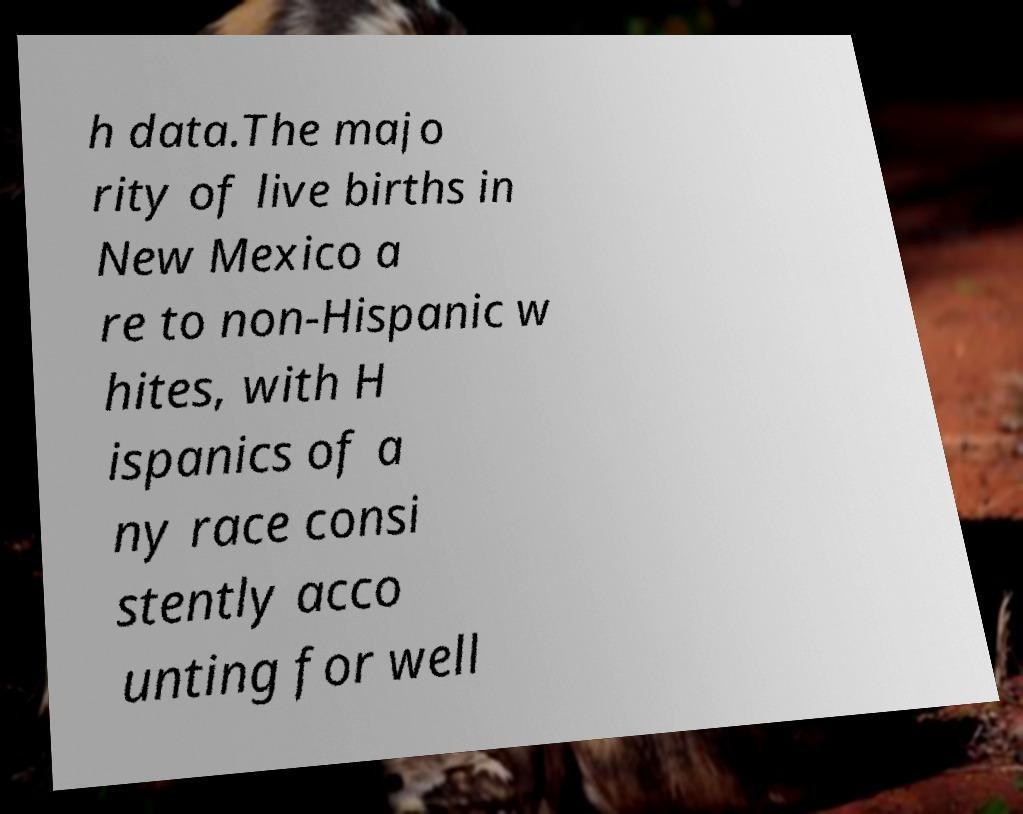There's text embedded in this image that I need extracted. Can you transcribe it verbatim? h data.The majo rity of live births in New Mexico a re to non-Hispanic w hites, with H ispanics of a ny race consi stently acco unting for well 